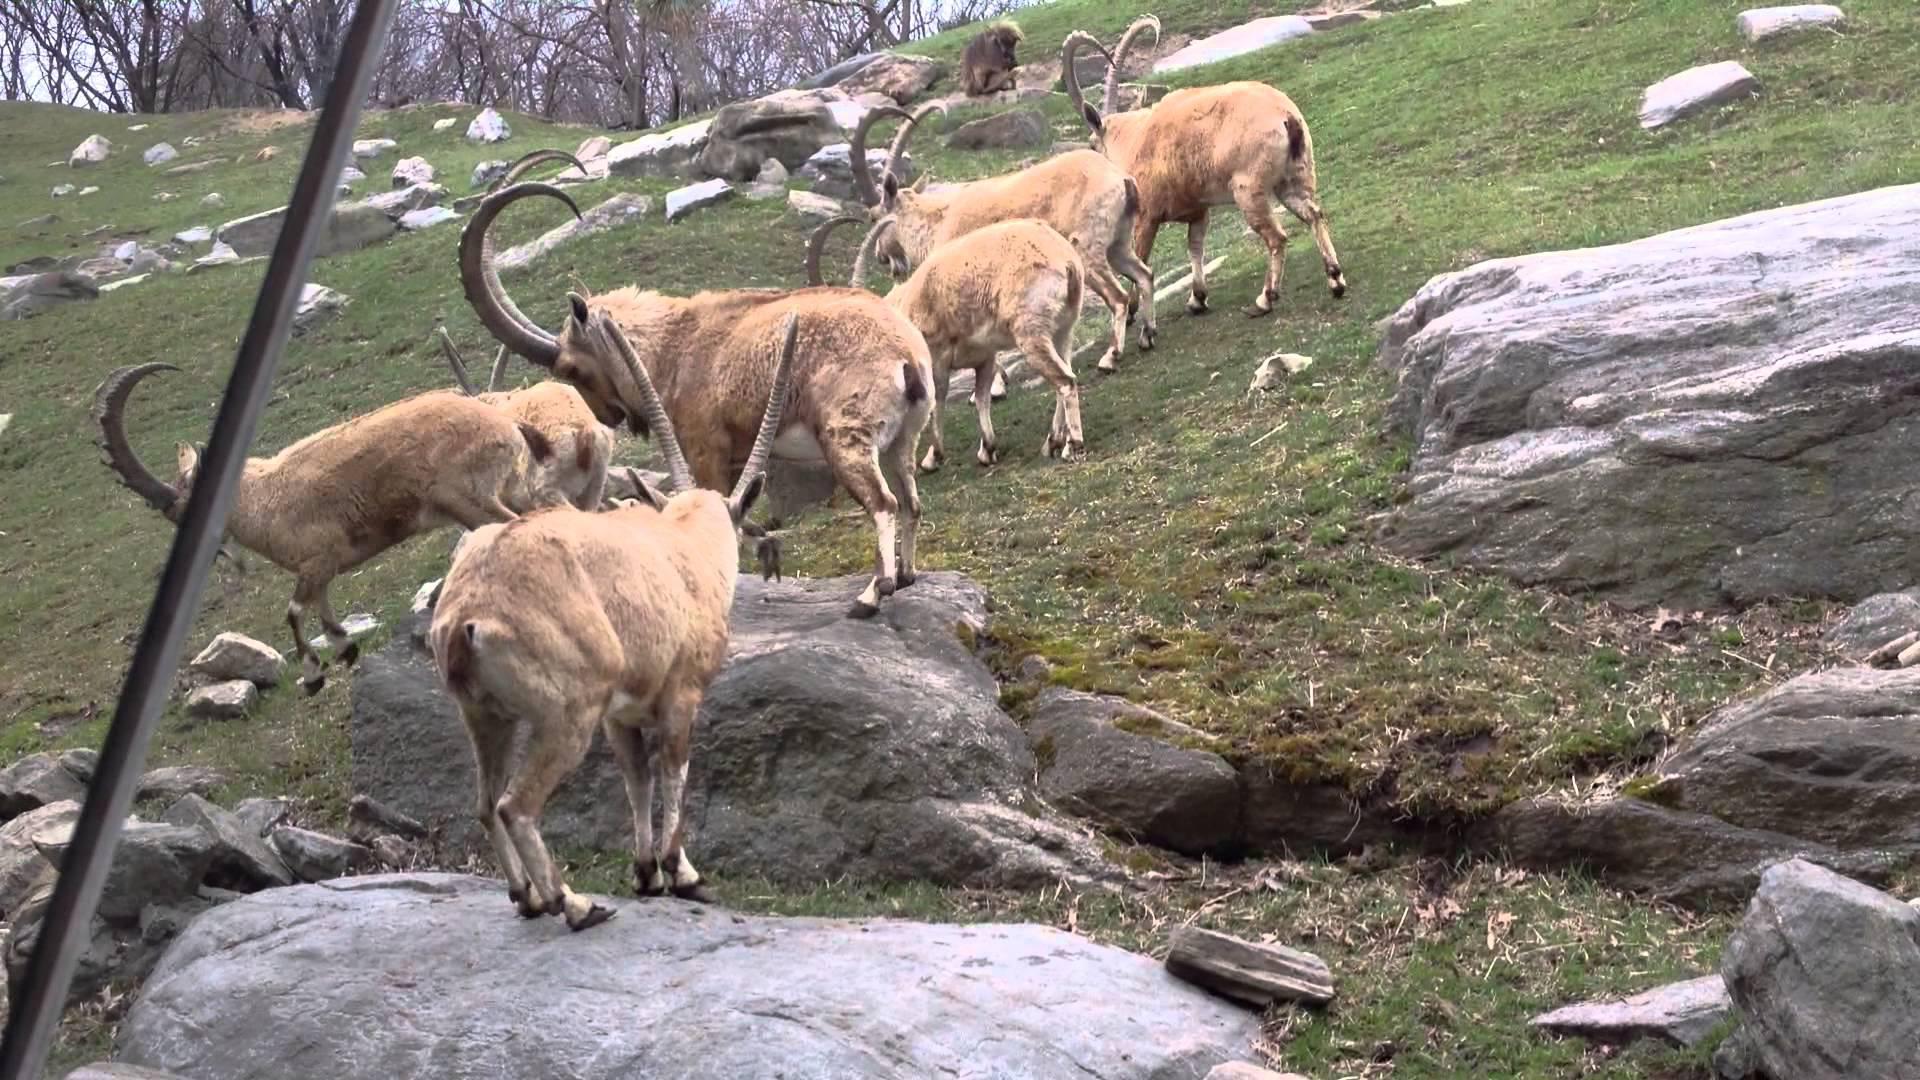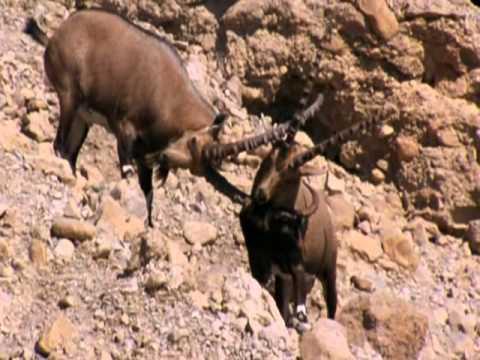The first image is the image on the left, the second image is the image on the right. Evaluate the accuracy of this statement regarding the images: "Two rams are locking horns in each of the images.". Is it true? Answer yes or no. No. 